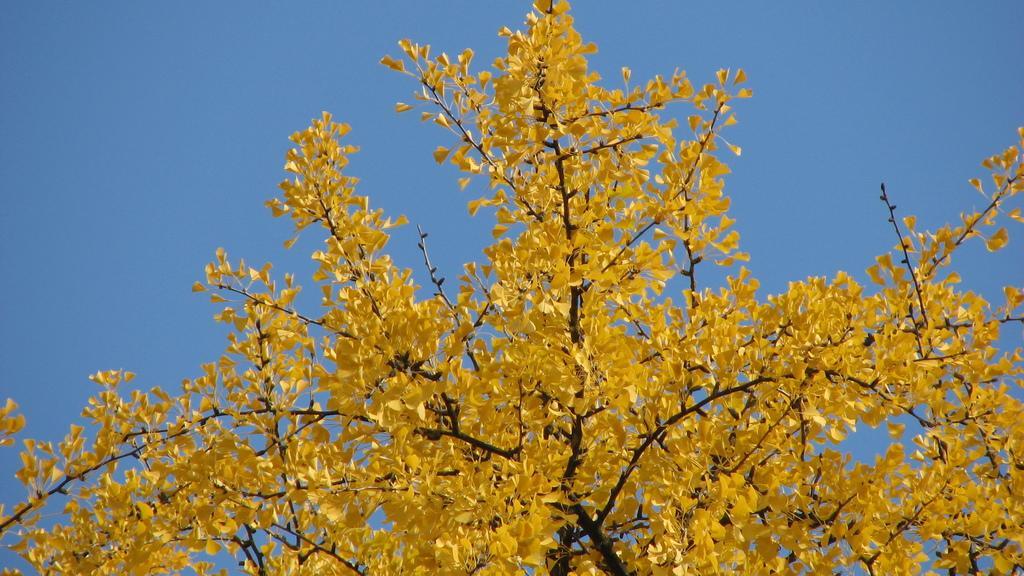Please provide a concise description of this image. In this picture we can see a tree and in the background we can see a sky. 